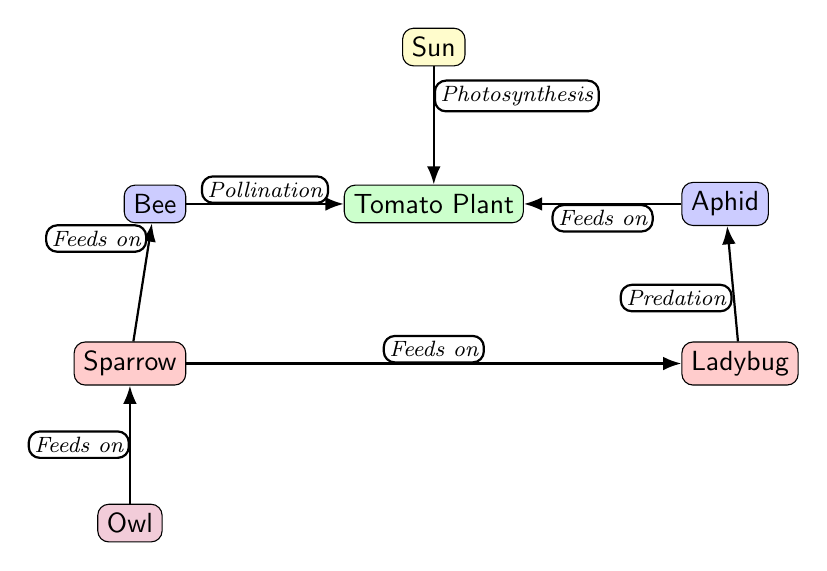What is the producer in the food chain? The producer is the entity that creates its own energy through photosynthesis. In this diagram, the tomato plant is identified as the producer.
Answer: Tomato Plant How many predators are present in the diagram? The diagram identifies two predators: the ladybug and the sparrow. By counting the nodes labeled as predators, we see there are exactly two.
Answer: 2 What does the bee do in relation to the tomato plant? The bee is involved in pollination, which means it helps in the reproduction of the tomato plant by transferring pollen. This relationship is depicted with an edge marked "Pollination" connecting the bee and the tomato plant.
Answer: Pollination Which animal feeds on the aphid? The ladybug feeds on the aphid, as indicated by the edge labeled "Predation" connecting the ladybug to the aphid node.
Answer: Ladybug What is the apex predator in the food chain? The apex predator is at the top of the food chain and feeds on the next level down. In this diagram, the owl is identified as the apex predator, as it is not eaten by any other organism depicted.
Answer: Owl What is the relationship between the sparrow and the bee? The relationship is that the sparrow feeds on the bee, which is indicated by the edge labeled "Feeds on" connecting the sparrow to the bee.
Answer: Feeds on How does the energy flow to the tomato plant? Energy flows to the tomato plant through photosynthesis, which is represented in the diagram by the edge labeled "Photosynthesis" that connects the sun to the tomato plant.
Answer: Photosynthesis Which node represents the pest in the garden? The aphid represents the pest in the vegetable garden, as it is typically known for being harmful to plants, specifically the tomato plant in this case.
Answer: Aphid What is the role of the owl in this food chain? The owl serves as an apex predator that feeds on the sparrow, which means it is at the top of the food chain and does not have any natural enemies depicted in this diagram.
Answer: Feeds on 